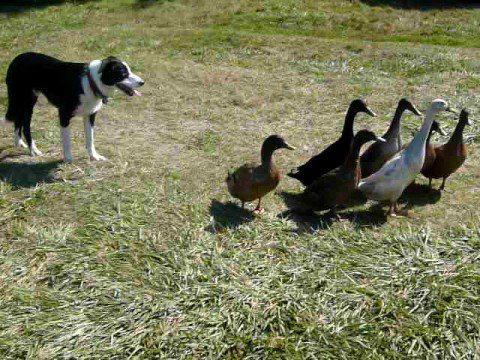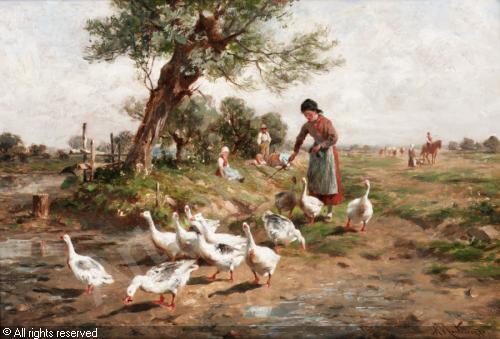The first image is the image on the left, the second image is the image on the right. For the images shown, is this caption "A single woman is standing with birds in the image on the left." true? Answer yes or no. No. The first image is the image on the left, the second image is the image on the right. Evaluate the accuracy of this statement regarding the images: "One image shows a dog standing on grass behind a small flock of duck-like birds.". Is it true? Answer yes or no. Yes. 